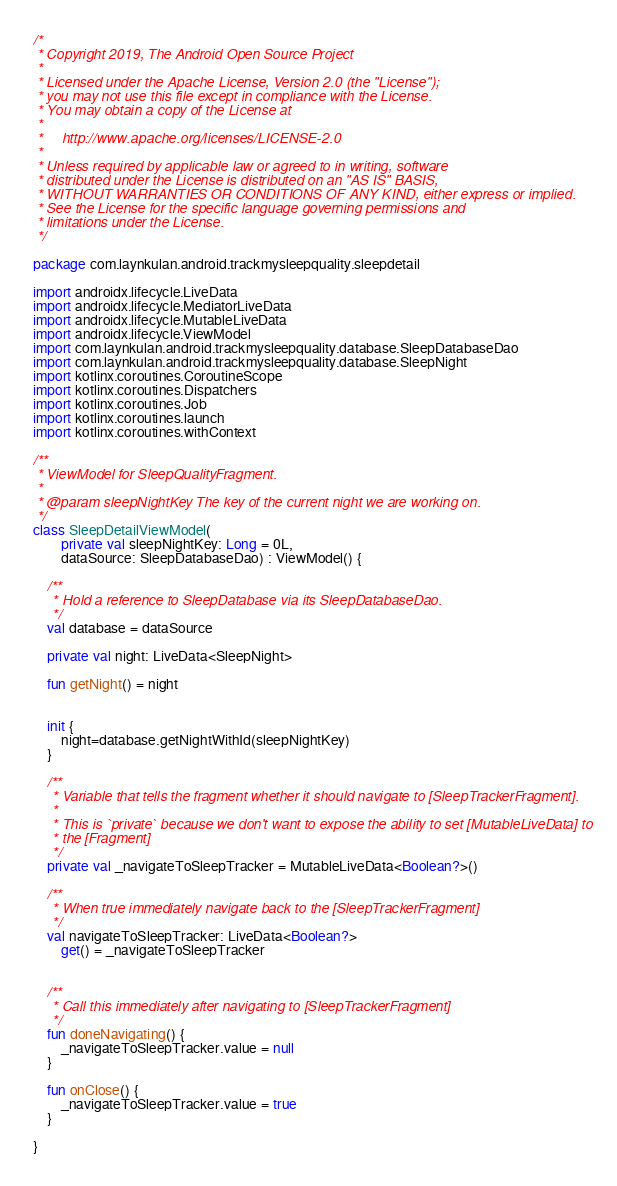Convert code to text. <code><loc_0><loc_0><loc_500><loc_500><_Kotlin_>/*
 * Copyright 2019, The Android Open Source Project
 *
 * Licensed under the Apache License, Version 2.0 (the "License");
 * you may not use this file except in compliance with the License.
 * You may obtain a copy of the License at
 *
 *     http://www.apache.org/licenses/LICENSE-2.0
 *
 * Unless required by applicable law or agreed to in writing, software
 * distributed under the License is distributed on an "AS IS" BASIS,
 * WITHOUT WARRANTIES OR CONDITIONS OF ANY KIND, either express or implied.
 * See the License for the specific language governing permissions and
 * limitations under the License.
 */

package com.laynkulan.android.trackmysleepquality.sleepdetail

import androidx.lifecycle.LiveData
import androidx.lifecycle.MediatorLiveData
import androidx.lifecycle.MutableLiveData
import androidx.lifecycle.ViewModel
import com.laynkulan.android.trackmysleepquality.database.SleepDatabaseDao
import com.laynkulan.android.trackmysleepquality.database.SleepNight
import kotlinx.coroutines.CoroutineScope
import kotlinx.coroutines.Dispatchers
import kotlinx.coroutines.Job
import kotlinx.coroutines.launch
import kotlinx.coroutines.withContext

/**
 * ViewModel for SleepQualityFragment.
 *
 * @param sleepNightKey The key of the current night we are working on.
 */
class SleepDetailViewModel(
        private val sleepNightKey: Long = 0L,
        dataSource: SleepDatabaseDao) : ViewModel() {

    /**
     * Hold a reference to SleepDatabase via its SleepDatabaseDao.
     */
    val database = dataSource

    private val night: LiveData<SleepNight>

    fun getNight() = night


    init {
        night=database.getNightWithId(sleepNightKey)
    }

    /**
     * Variable that tells the fragment whether it should navigate to [SleepTrackerFragment].
     *
     * This is `private` because we don't want to expose the ability to set [MutableLiveData] to
     * the [Fragment]
     */
    private val _navigateToSleepTracker = MutableLiveData<Boolean?>()

    /**
     * When true immediately navigate back to the [SleepTrackerFragment]
     */
    val navigateToSleepTracker: LiveData<Boolean?>
        get() = _navigateToSleepTracker


    /**
     * Call this immediately after navigating to [SleepTrackerFragment]
     */
    fun doneNavigating() {
        _navigateToSleepTracker.value = null
    }

    fun onClose() {
        _navigateToSleepTracker.value = true
    }

}</code> 